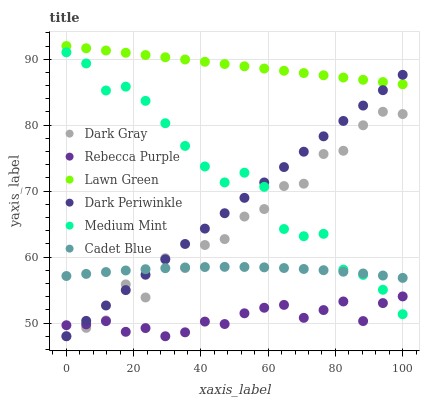Does Rebecca Purple have the minimum area under the curve?
Answer yes or no. Yes. Does Lawn Green have the maximum area under the curve?
Answer yes or no. Yes. Does Cadet Blue have the minimum area under the curve?
Answer yes or no. No. Does Cadet Blue have the maximum area under the curve?
Answer yes or no. No. Is Dark Periwinkle the smoothest?
Answer yes or no. Yes. Is Dark Gray the roughest?
Answer yes or no. Yes. Is Lawn Green the smoothest?
Answer yes or no. No. Is Lawn Green the roughest?
Answer yes or no. No. Does Dark Gray have the lowest value?
Answer yes or no. Yes. Does Cadet Blue have the lowest value?
Answer yes or no. No. Does Lawn Green have the highest value?
Answer yes or no. Yes. Does Cadet Blue have the highest value?
Answer yes or no. No. Is Rebecca Purple less than Lawn Green?
Answer yes or no. Yes. Is Lawn Green greater than Dark Gray?
Answer yes or no. Yes. Does Dark Periwinkle intersect Medium Mint?
Answer yes or no. Yes. Is Dark Periwinkle less than Medium Mint?
Answer yes or no. No. Is Dark Periwinkle greater than Medium Mint?
Answer yes or no. No. Does Rebecca Purple intersect Lawn Green?
Answer yes or no. No. 